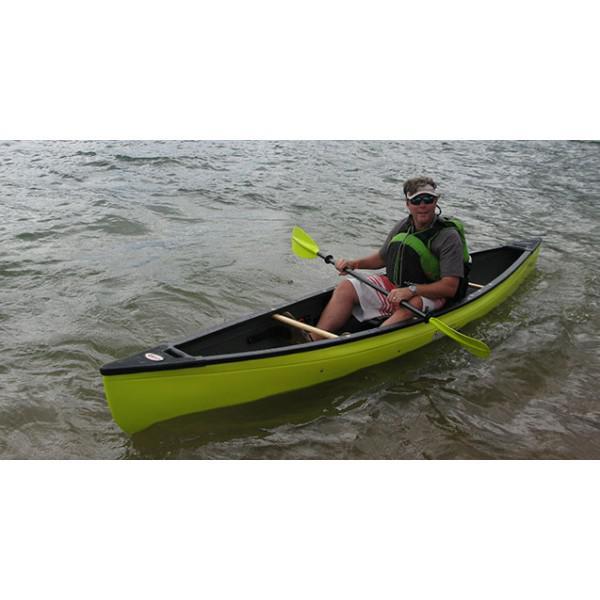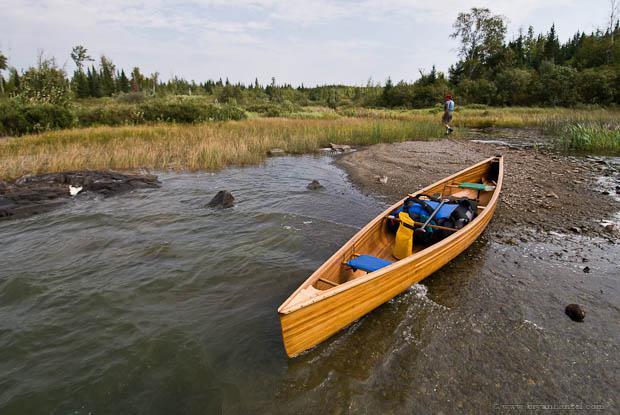The first image is the image on the left, the second image is the image on the right. Evaluate the accuracy of this statement regarding the images: "In one image, a man in a canoe is holding an oar and wearing a life vest and hat.". Is it true? Answer yes or no. Yes. The first image is the image on the left, the second image is the image on the right. Given the left and right images, does the statement "A person is paddling a canoe diagonally to the left in the left image." hold true? Answer yes or no. Yes. 